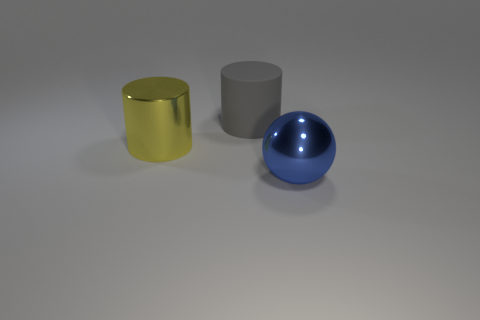Add 3 big yellow shiny things. How many objects exist? 6 Subtract all cylinders. How many objects are left? 1 Subtract 0 green cubes. How many objects are left? 3 Subtract all large shiny objects. Subtract all large yellow things. How many objects are left? 0 Add 3 yellow cylinders. How many yellow cylinders are left? 4 Add 2 yellow metallic cylinders. How many yellow metallic cylinders exist? 3 